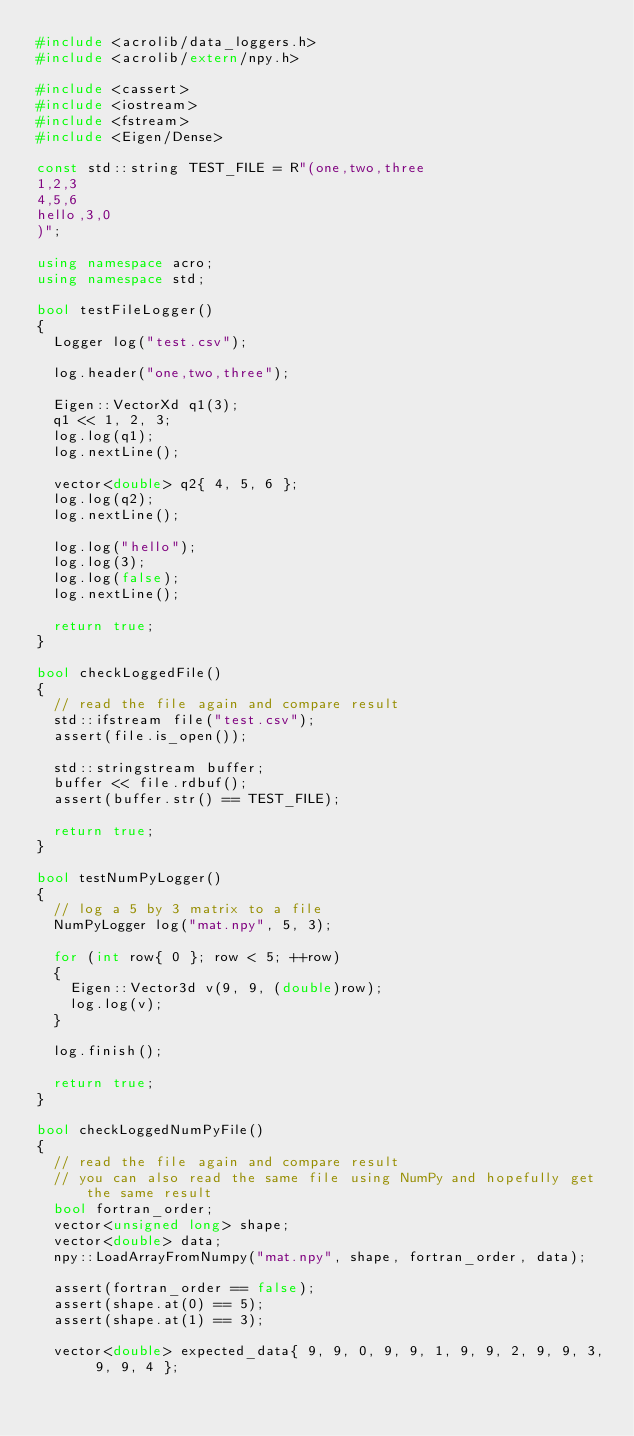<code> <loc_0><loc_0><loc_500><loc_500><_C++_>#include <acrolib/data_loggers.h>
#include <acrolib/extern/npy.h>

#include <cassert>
#include <iostream>
#include <fstream>
#include <Eigen/Dense>

const std::string TEST_FILE = R"(one,two,three
1,2,3
4,5,6
hello,3,0
)";

using namespace acro;
using namespace std;

bool testFileLogger()
{
  Logger log("test.csv");

  log.header("one,two,three");

  Eigen::VectorXd q1(3);
  q1 << 1, 2, 3;
  log.log(q1);
  log.nextLine();

  vector<double> q2{ 4, 5, 6 };
  log.log(q2);
  log.nextLine();

  log.log("hello");
  log.log(3);
  log.log(false);
  log.nextLine();

  return true;
}

bool checkLoggedFile()
{
  // read the file again and compare result
  std::ifstream file("test.csv");
  assert(file.is_open());

  std::stringstream buffer;
  buffer << file.rdbuf();
  assert(buffer.str() == TEST_FILE);

  return true;
}

bool testNumPyLogger()
{
  // log a 5 by 3 matrix to a file
  NumPyLogger log("mat.npy", 5, 3);

  for (int row{ 0 }; row < 5; ++row)
  {
    Eigen::Vector3d v(9, 9, (double)row);
    log.log(v);
  }

  log.finish();

  return true;
}

bool checkLoggedNumPyFile()
{
  // read the file again and compare result
  // you can also read the same file using NumPy and hopefully get the same result
  bool fortran_order;
  vector<unsigned long> shape;
  vector<double> data;
  npy::LoadArrayFromNumpy("mat.npy", shape, fortran_order, data);

  assert(fortran_order == false);
  assert(shape.at(0) == 5);
  assert(shape.at(1) == 3);

  vector<double> expected_data{ 9, 9, 0, 9, 9, 1, 9, 9, 2, 9, 9, 3, 9, 9, 4 };
</code> 